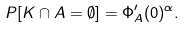Convert formula to latex. <formula><loc_0><loc_0><loc_500><loc_500>P [ K \cap A = \emptyset ] = \Phi _ { A } ^ { \prime } ( 0 ) ^ { \alpha } .</formula> 